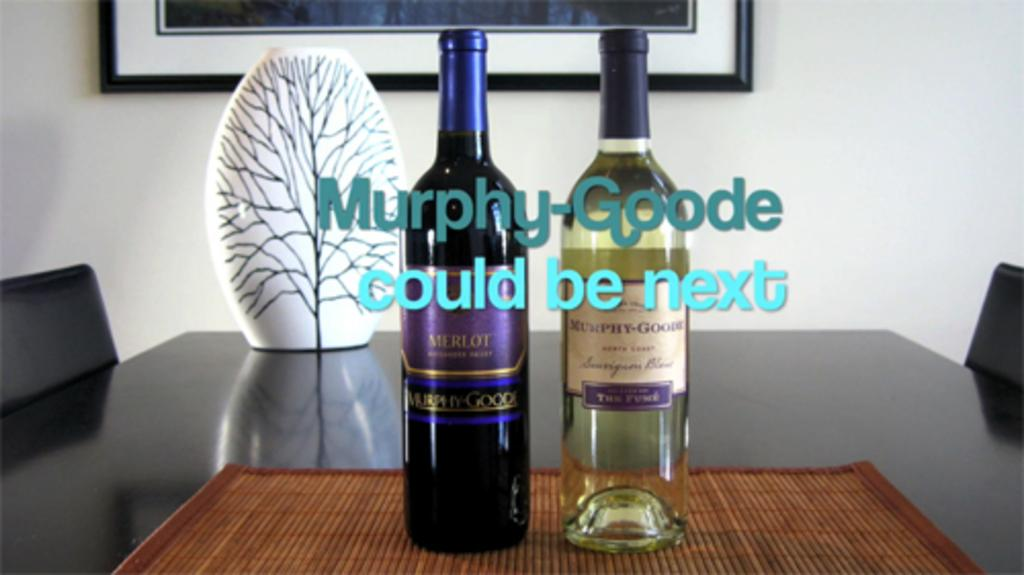How many bottles are on the table in the image? There are two bottles on the table in the image. What else can be seen on the table besides the bottles? There is a decorative item on the table. What type of furniture is visible in the image? There are chairs in the image. What can be seen in the background of the image? There is a wall and a frame in the background of the image. How many girls are standing in line in the image? There are no girls or lines present in the image. What is the thumb doing in the image? There is no thumb visible in the image. 